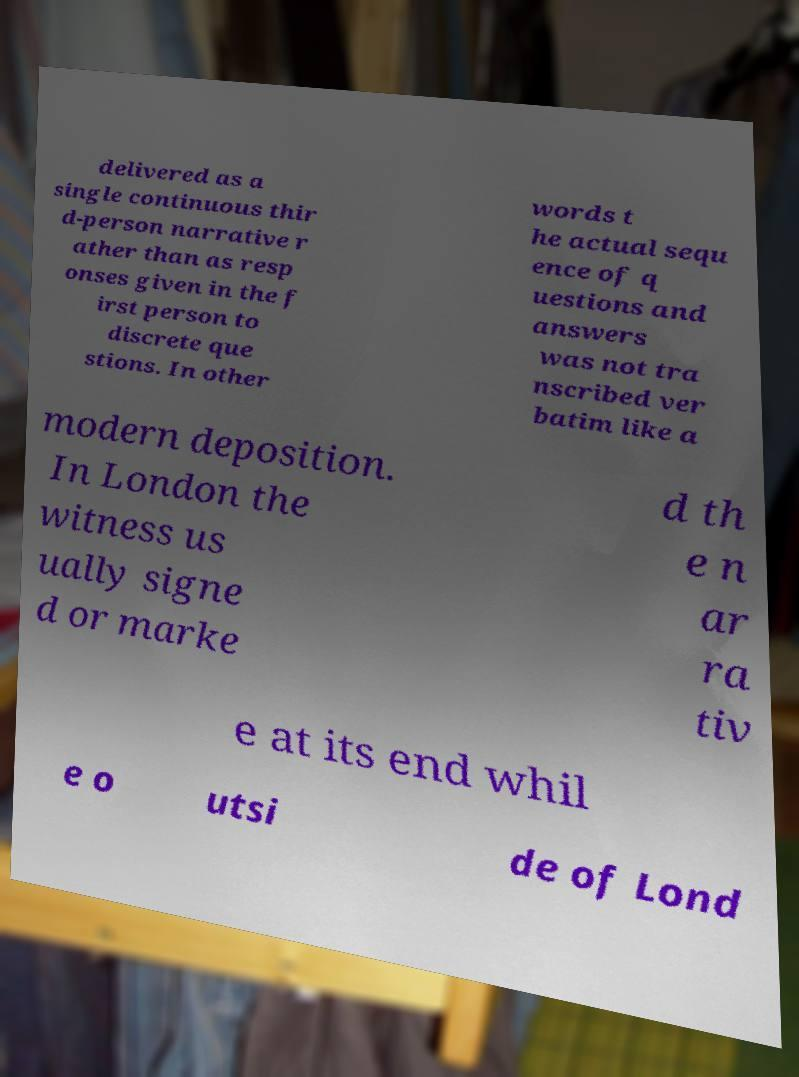What messages or text are displayed in this image? I need them in a readable, typed format. delivered as a single continuous thir d-person narrative r ather than as resp onses given in the f irst person to discrete que stions. In other words t he actual sequ ence of q uestions and answers was not tra nscribed ver batim like a modern deposition. In London the witness us ually signe d or marke d th e n ar ra tiv e at its end whil e o utsi de of Lond 